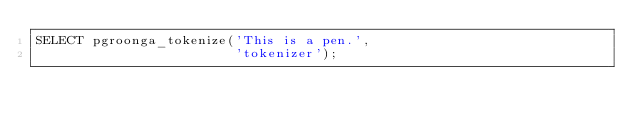<code> <loc_0><loc_0><loc_500><loc_500><_SQL_>SELECT pgroonga_tokenize('This is a pen.',
                         'tokenizer');
</code> 